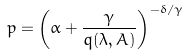<formula> <loc_0><loc_0><loc_500><loc_500>p = \left ( \alpha + \frac { \gamma } { q ( \lambda , A ) } \right ) ^ { - \delta / \gamma }</formula> 